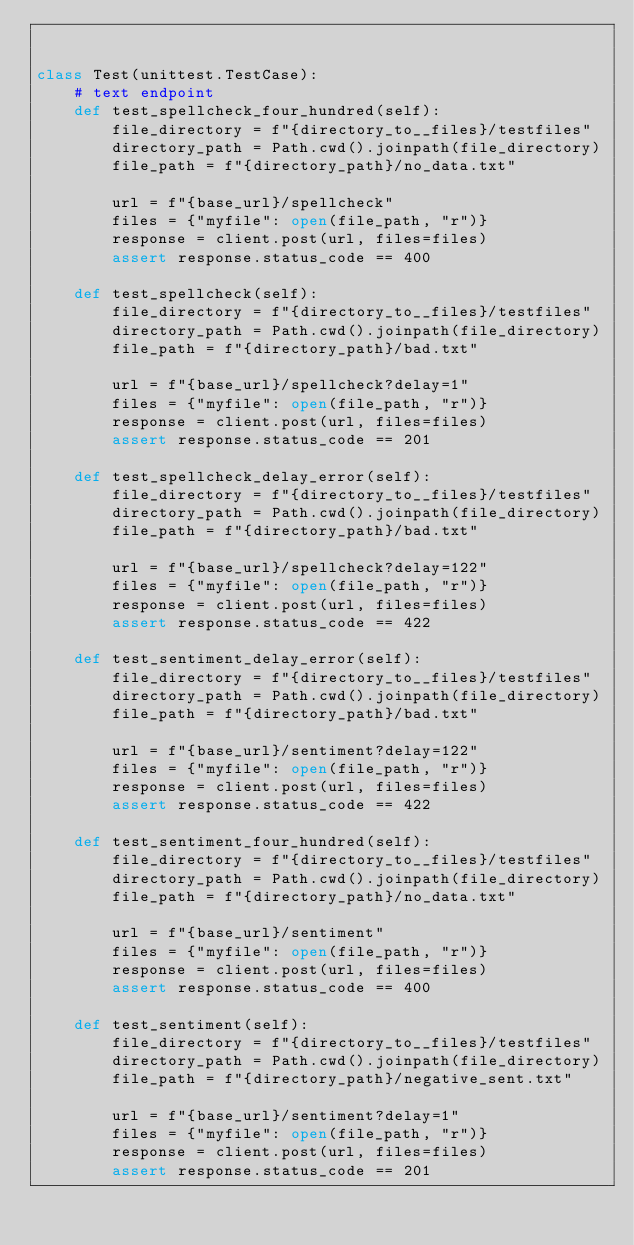Convert code to text. <code><loc_0><loc_0><loc_500><loc_500><_Python_>

class Test(unittest.TestCase):
    # text endpoint
    def test_spellcheck_four_hundred(self):
        file_directory = f"{directory_to__files}/testfiles"
        directory_path = Path.cwd().joinpath(file_directory)
        file_path = f"{directory_path}/no_data.txt"

        url = f"{base_url}/spellcheck"
        files = {"myfile": open(file_path, "r")}
        response = client.post(url, files=files)
        assert response.status_code == 400

    def test_spellcheck(self):
        file_directory = f"{directory_to__files}/testfiles"
        directory_path = Path.cwd().joinpath(file_directory)
        file_path = f"{directory_path}/bad.txt"

        url = f"{base_url}/spellcheck?delay=1"
        files = {"myfile": open(file_path, "r")}
        response = client.post(url, files=files)
        assert response.status_code == 201

    def test_spellcheck_delay_error(self):
        file_directory = f"{directory_to__files}/testfiles"
        directory_path = Path.cwd().joinpath(file_directory)
        file_path = f"{directory_path}/bad.txt"

        url = f"{base_url}/spellcheck?delay=122"
        files = {"myfile": open(file_path, "r")}
        response = client.post(url, files=files)
        assert response.status_code == 422

    def test_sentiment_delay_error(self):
        file_directory = f"{directory_to__files}/testfiles"
        directory_path = Path.cwd().joinpath(file_directory)
        file_path = f"{directory_path}/bad.txt"

        url = f"{base_url}/sentiment?delay=122"
        files = {"myfile": open(file_path, "r")}
        response = client.post(url, files=files)
        assert response.status_code == 422

    def test_sentiment_four_hundred(self):
        file_directory = f"{directory_to__files}/testfiles"
        directory_path = Path.cwd().joinpath(file_directory)
        file_path = f"{directory_path}/no_data.txt"

        url = f"{base_url}/sentiment"
        files = {"myfile": open(file_path, "r")}
        response = client.post(url, files=files)
        assert response.status_code == 400

    def test_sentiment(self):
        file_directory = f"{directory_to__files}/testfiles"
        directory_path = Path.cwd().joinpath(file_directory)
        file_path = f"{directory_path}/negative_sent.txt"

        url = f"{base_url}/sentiment?delay=1"
        files = {"myfile": open(file_path, "r")}
        response = client.post(url, files=files)
        assert response.status_code == 201
</code> 